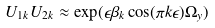Convert formula to latex. <formula><loc_0><loc_0><loc_500><loc_500>U _ { 1 k } U _ { 2 k } \approx \exp ( \epsilon \beta _ { k } \cos ( \pi k \epsilon ) \Omega _ { y } )</formula> 